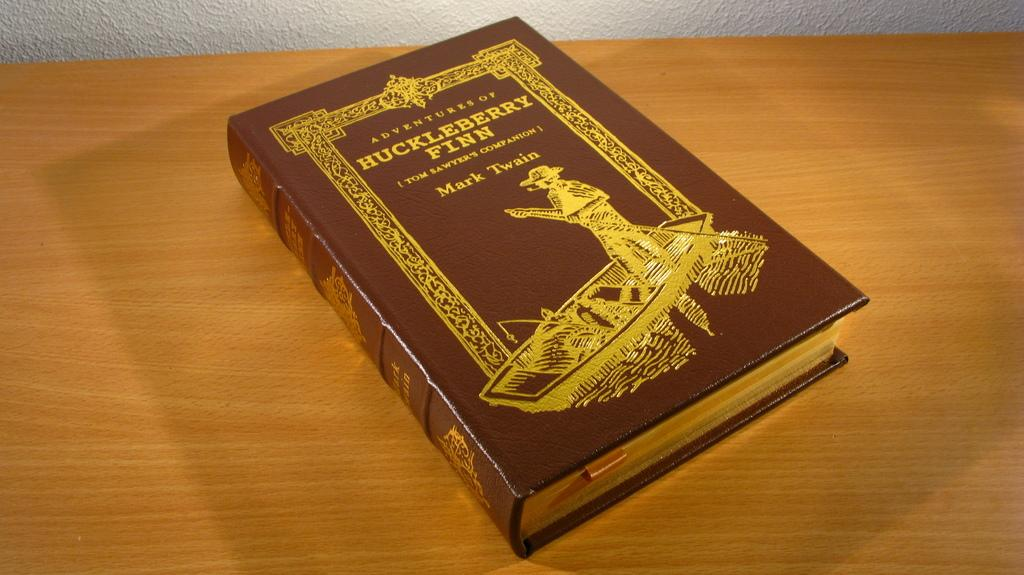Provide a one-sentence caption for the provided image. An ornate volume of Huck Fin sits on a wooden surface. 